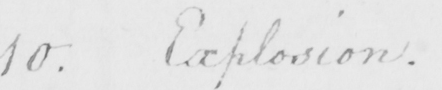Please transcribe the handwritten text in this image. 10 . Explosion . 